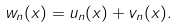<formula> <loc_0><loc_0><loc_500><loc_500>w _ { n } ( x ) = u _ { n } ( x ) + v _ { n } ( x ) .</formula> 